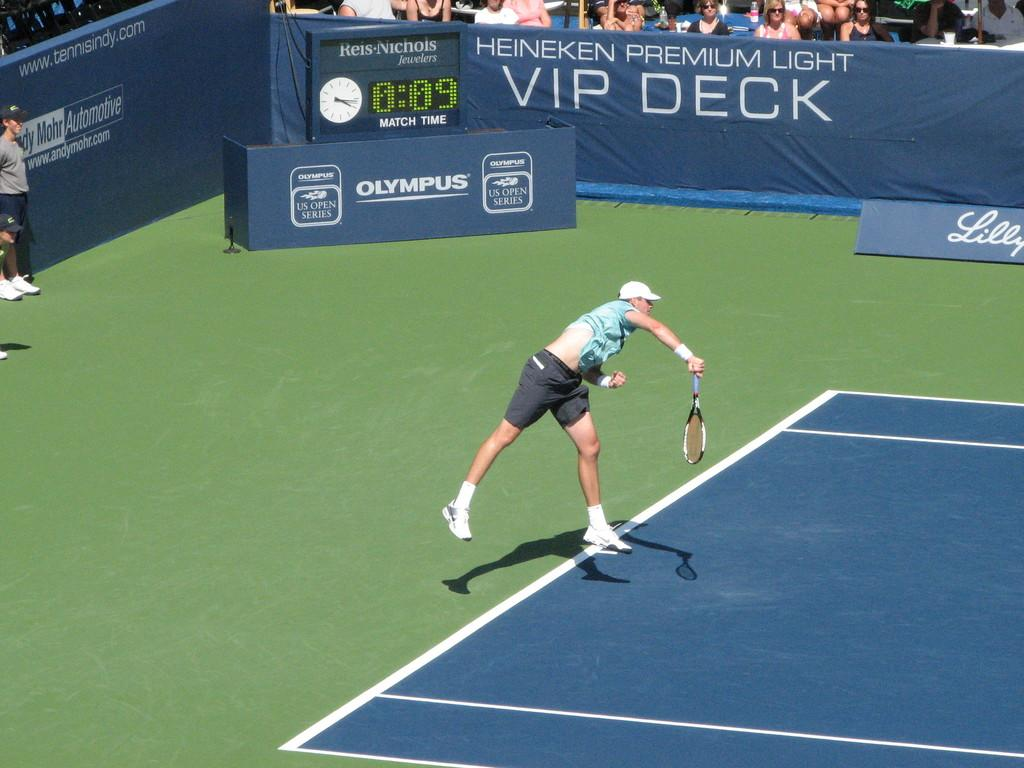Who is the main subject in the image? There is a man in the image. What is the man doing in the image? The man is jumping. What object is the man holding in the image? The man is holding a tennis racket. Can you describe the people behind the man? There are people behind the man, but their actions or features are not mentioned in the facts. What is the hoarding visible in the image? The facts do not provide any information about the hoarding, so we cannot describe it. How many dogs are present in the image? There are no dogs mentioned or visible in the image. 